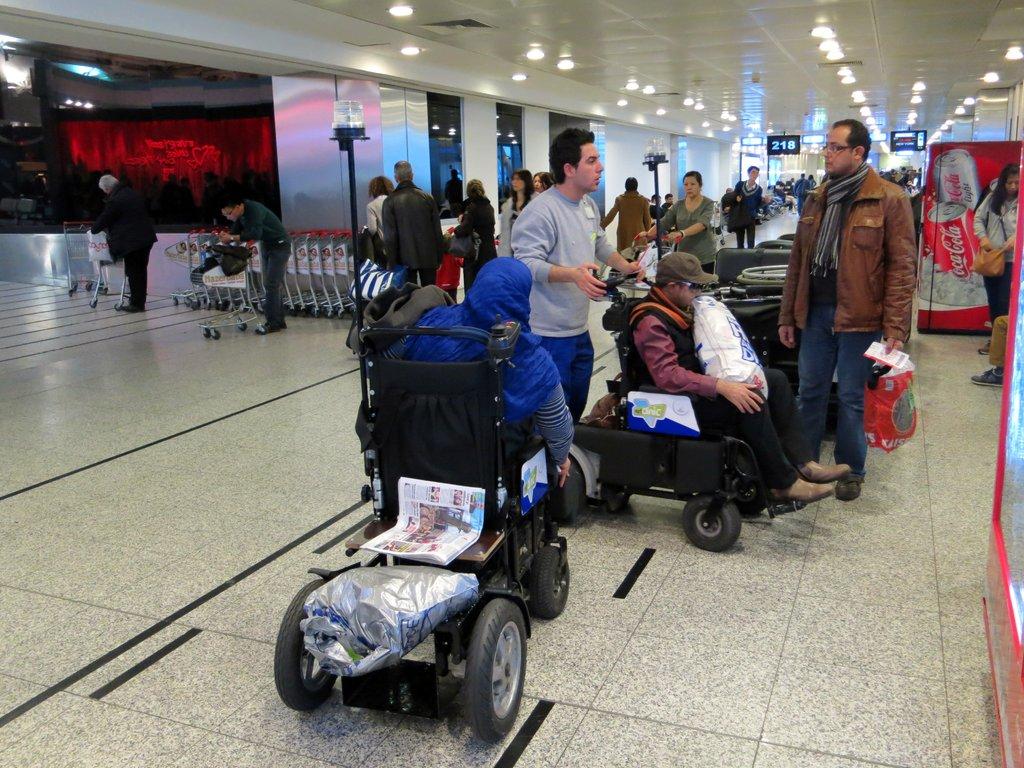What brand of soft drink is in the vending machine?
Offer a very short reply. Coca cola. What gate number is on the small black sign in the distance?
Make the answer very short. 218. 